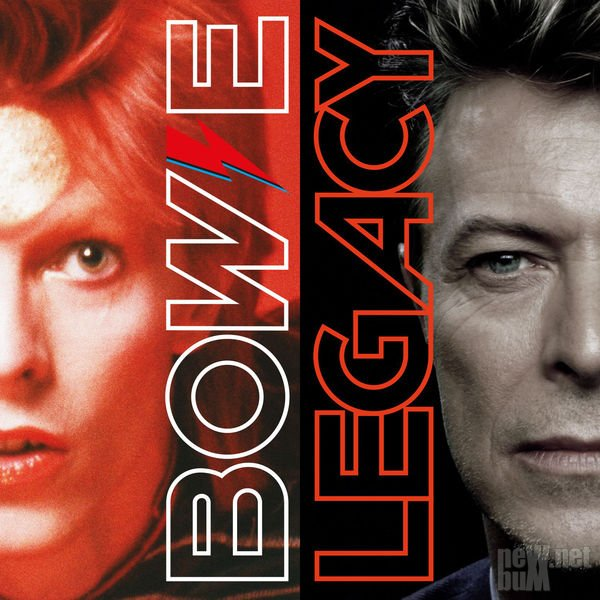What might be the significance of the lightning bolt design across the face in the left portrait? The lightning bolt design across the face in the left portrait is likely a significant symbol of an alter ego or stage persona. Given its striking visual appeal, it may represent energy, transformation, and a dramatic cultural or musical impact. The bolt stands out boldly against the individual's pale skin and vibrant hair, indicating it's an intentional and iconic image associated with their public identity. This design could mark a phase in the individual's career characterized by a bold aesthetic, aligning with themes or performances that were experimental and influential. The bolt, commonly associated with electricity, could metaphorically signify a powerful and dynamic presence in their professional field, suggesting a period of electrifying innovation and creativity. 